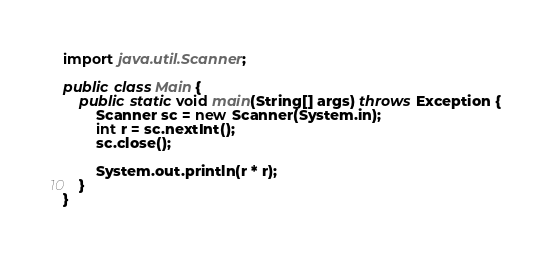Convert code to text. <code><loc_0><loc_0><loc_500><loc_500><_Java_>import java.util.Scanner;

public class Main {
	public static void main(String[] args) throws Exception {
		Scanner sc = new Scanner(System.in);
		int r = sc.nextInt();
		sc.close();

		System.out.println(r * r);
	}
}
</code> 